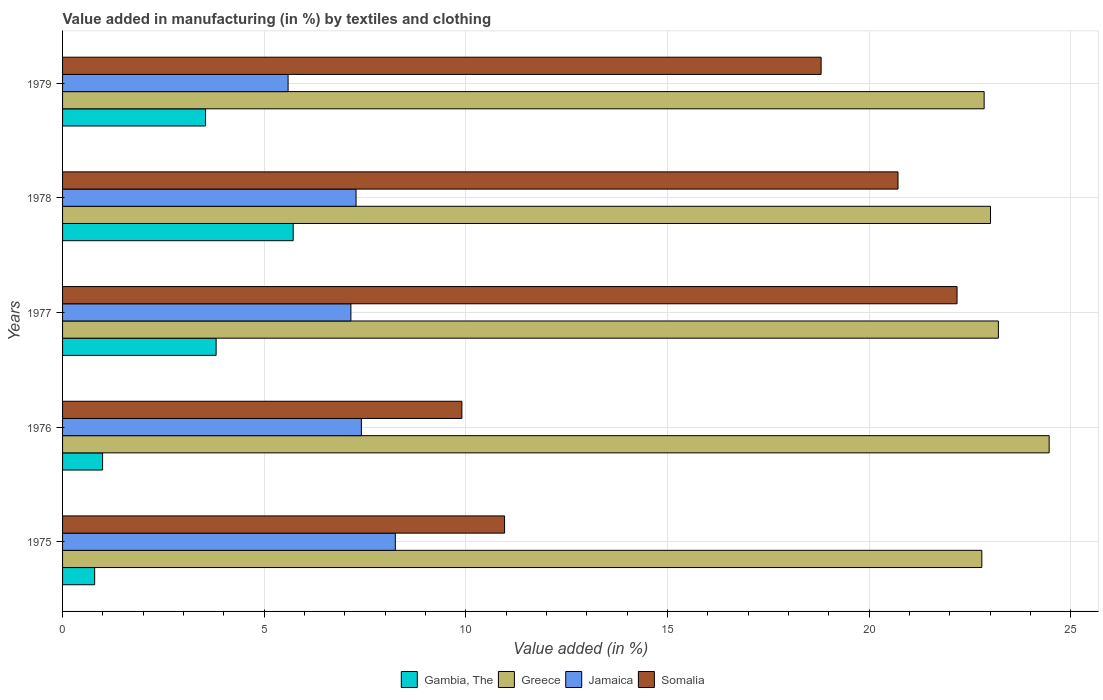Are the number of bars per tick equal to the number of legend labels?
Offer a terse response. Yes. How many bars are there on the 1st tick from the top?
Provide a succinct answer. 4. What is the label of the 1st group of bars from the top?
Provide a succinct answer. 1979. In how many cases, is the number of bars for a given year not equal to the number of legend labels?
Offer a terse response. 0. What is the percentage of value added in manufacturing by textiles and clothing in Somalia in 1978?
Provide a short and direct response. 20.72. Across all years, what is the maximum percentage of value added in manufacturing by textiles and clothing in Jamaica?
Provide a succinct answer. 8.25. Across all years, what is the minimum percentage of value added in manufacturing by textiles and clothing in Gambia, The?
Make the answer very short. 0.8. In which year was the percentage of value added in manufacturing by textiles and clothing in Jamaica maximum?
Offer a very short reply. 1975. In which year was the percentage of value added in manufacturing by textiles and clothing in Jamaica minimum?
Give a very brief answer. 1979. What is the total percentage of value added in manufacturing by textiles and clothing in Greece in the graph?
Make the answer very short. 116.32. What is the difference between the percentage of value added in manufacturing by textiles and clothing in Greece in 1975 and that in 1976?
Your answer should be very brief. -1.67. What is the difference between the percentage of value added in manufacturing by textiles and clothing in Gambia, The in 1978 and the percentage of value added in manufacturing by textiles and clothing in Somalia in 1976?
Make the answer very short. -4.18. What is the average percentage of value added in manufacturing by textiles and clothing in Greece per year?
Offer a very short reply. 23.26. In the year 1976, what is the difference between the percentage of value added in manufacturing by textiles and clothing in Gambia, The and percentage of value added in manufacturing by textiles and clothing in Greece?
Your answer should be compact. -23.47. In how many years, is the percentage of value added in manufacturing by textiles and clothing in Somalia greater than 23 %?
Make the answer very short. 0. What is the ratio of the percentage of value added in manufacturing by textiles and clothing in Jamaica in 1975 to that in 1976?
Your answer should be very brief. 1.11. Is the difference between the percentage of value added in manufacturing by textiles and clothing in Gambia, The in 1976 and 1979 greater than the difference between the percentage of value added in manufacturing by textiles and clothing in Greece in 1976 and 1979?
Your answer should be very brief. No. What is the difference between the highest and the second highest percentage of value added in manufacturing by textiles and clothing in Somalia?
Offer a very short reply. 1.46. What is the difference between the highest and the lowest percentage of value added in manufacturing by textiles and clothing in Gambia, The?
Make the answer very short. 4.92. In how many years, is the percentage of value added in manufacturing by textiles and clothing in Jamaica greater than the average percentage of value added in manufacturing by textiles and clothing in Jamaica taken over all years?
Ensure brevity in your answer.  4. Is it the case that in every year, the sum of the percentage of value added in manufacturing by textiles and clothing in Somalia and percentage of value added in manufacturing by textiles and clothing in Gambia, The is greater than the sum of percentage of value added in manufacturing by textiles and clothing in Jamaica and percentage of value added in manufacturing by textiles and clothing in Greece?
Offer a terse response. No. What does the 4th bar from the bottom in 1975 represents?
Offer a very short reply. Somalia. Are all the bars in the graph horizontal?
Your response must be concise. Yes. Are the values on the major ticks of X-axis written in scientific E-notation?
Your response must be concise. No. Does the graph contain any zero values?
Ensure brevity in your answer.  No. Does the graph contain grids?
Offer a terse response. Yes. How many legend labels are there?
Offer a very short reply. 4. How are the legend labels stacked?
Your answer should be very brief. Horizontal. What is the title of the graph?
Your answer should be compact. Value added in manufacturing (in %) by textiles and clothing. What is the label or title of the X-axis?
Ensure brevity in your answer.  Value added (in %). What is the Value added (in %) of Gambia, The in 1975?
Your answer should be compact. 0.8. What is the Value added (in %) of Greece in 1975?
Offer a very short reply. 22.79. What is the Value added (in %) of Jamaica in 1975?
Your answer should be compact. 8.25. What is the Value added (in %) in Somalia in 1975?
Your response must be concise. 10.96. What is the Value added (in %) in Gambia, The in 1976?
Provide a short and direct response. 0.99. What is the Value added (in %) in Greece in 1976?
Ensure brevity in your answer.  24.46. What is the Value added (in %) in Jamaica in 1976?
Offer a terse response. 7.41. What is the Value added (in %) in Somalia in 1976?
Offer a terse response. 9.9. What is the Value added (in %) of Gambia, The in 1977?
Make the answer very short. 3.81. What is the Value added (in %) in Greece in 1977?
Offer a terse response. 23.2. What is the Value added (in %) in Jamaica in 1977?
Offer a terse response. 7.15. What is the Value added (in %) of Somalia in 1977?
Your response must be concise. 22.18. What is the Value added (in %) of Gambia, The in 1978?
Offer a terse response. 5.72. What is the Value added (in %) in Greece in 1978?
Provide a short and direct response. 23.01. What is the Value added (in %) in Jamaica in 1978?
Make the answer very short. 7.28. What is the Value added (in %) in Somalia in 1978?
Provide a short and direct response. 20.72. What is the Value added (in %) of Gambia, The in 1979?
Provide a short and direct response. 3.55. What is the Value added (in %) of Greece in 1979?
Provide a succinct answer. 22.85. What is the Value added (in %) of Jamaica in 1979?
Your answer should be very brief. 5.59. What is the Value added (in %) of Somalia in 1979?
Your response must be concise. 18.81. Across all years, what is the maximum Value added (in %) of Gambia, The?
Your answer should be very brief. 5.72. Across all years, what is the maximum Value added (in %) in Greece?
Provide a succinct answer. 24.46. Across all years, what is the maximum Value added (in %) in Jamaica?
Your answer should be compact. 8.25. Across all years, what is the maximum Value added (in %) of Somalia?
Offer a very short reply. 22.18. Across all years, what is the minimum Value added (in %) in Gambia, The?
Provide a short and direct response. 0.8. Across all years, what is the minimum Value added (in %) of Greece?
Your answer should be compact. 22.79. Across all years, what is the minimum Value added (in %) in Jamaica?
Your answer should be very brief. 5.59. Across all years, what is the minimum Value added (in %) of Somalia?
Keep it short and to the point. 9.9. What is the total Value added (in %) of Gambia, The in the graph?
Your answer should be very brief. 14.86. What is the total Value added (in %) in Greece in the graph?
Provide a succinct answer. 116.32. What is the total Value added (in %) of Jamaica in the graph?
Your answer should be very brief. 35.68. What is the total Value added (in %) of Somalia in the graph?
Offer a very short reply. 82.57. What is the difference between the Value added (in %) of Gambia, The in 1975 and that in 1976?
Provide a short and direct response. -0.2. What is the difference between the Value added (in %) in Greece in 1975 and that in 1976?
Make the answer very short. -1.67. What is the difference between the Value added (in %) of Jamaica in 1975 and that in 1976?
Provide a short and direct response. 0.84. What is the difference between the Value added (in %) of Somalia in 1975 and that in 1976?
Your answer should be compact. 1.06. What is the difference between the Value added (in %) of Gambia, The in 1975 and that in 1977?
Provide a succinct answer. -3.01. What is the difference between the Value added (in %) of Greece in 1975 and that in 1977?
Offer a very short reply. -0.41. What is the difference between the Value added (in %) of Jamaica in 1975 and that in 1977?
Ensure brevity in your answer.  1.1. What is the difference between the Value added (in %) in Somalia in 1975 and that in 1977?
Ensure brevity in your answer.  -11.22. What is the difference between the Value added (in %) of Gambia, The in 1975 and that in 1978?
Your response must be concise. -4.92. What is the difference between the Value added (in %) of Greece in 1975 and that in 1978?
Offer a very short reply. -0.22. What is the difference between the Value added (in %) of Jamaica in 1975 and that in 1978?
Offer a terse response. 0.97. What is the difference between the Value added (in %) of Somalia in 1975 and that in 1978?
Keep it short and to the point. -9.76. What is the difference between the Value added (in %) in Gambia, The in 1975 and that in 1979?
Your response must be concise. -2.75. What is the difference between the Value added (in %) in Greece in 1975 and that in 1979?
Offer a very short reply. -0.06. What is the difference between the Value added (in %) in Jamaica in 1975 and that in 1979?
Make the answer very short. 2.66. What is the difference between the Value added (in %) in Somalia in 1975 and that in 1979?
Provide a short and direct response. -7.85. What is the difference between the Value added (in %) in Gambia, The in 1976 and that in 1977?
Your response must be concise. -2.81. What is the difference between the Value added (in %) of Greece in 1976 and that in 1977?
Your answer should be very brief. 1.26. What is the difference between the Value added (in %) of Jamaica in 1976 and that in 1977?
Offer a terse response. 0.26. What is the difference between the Value added (in %) in Somalia in 1976 and that in 1977?
Provide a short and direct response. -12.28. What is the difference between the Value added (in %) in Gambia, The in 1976 and that in 1978?
Ensure brevity in your answer.  -4.73. What is the difference between the Value added (in %) of Greece in 1976 and that in 1978?
Keep it short and to the point. 1.45. What is the difference between the Value added (in %) in Jamaica in 1976 and that in 1978?
Ensure brevity in your answer.  0.13. What is the difference between the Value added (in %) of Somalia in 1976 and that in 1978?
Your answer should be very brief. -10.81. What is the difference between the Value added (in %) of Gambia, The in 1976 and that in 1979?
Ensure brevity in your answer.  -2.55. What is the difference between the Value added (in %) in Greece in 1976 and that in 1979?
Make the answer very short. 1.61. What is the difference between the Value added (in %) of Jamaica in 1976 and that in 1979?
Make the answer very short. 1.82. What is the difference between the Value added (in %) of Somalia in 1976 and that in 1979?
Provide a succinct answer. -8.91. What is the difference between the Value added (in %) in Gambia, The in 1977 and that in 1978?
Offer a terse response. -1.91. What is the difference between the Value added (in %) in Greece in 1977 and that in 1978?
Provide a succinct answer. 0.2. What is the difference between the Value added (in %) of Jamaica in 1977 and that in 1978?
Provide a succinct answer. -0.13. What is the difference between the Value added (in %) in Somalia in 1977 and that in 1978?
Your response must be concise. 1.46. What is the difference between the Value added (in %) of Gambia, The in 1977 and that in 1979?
Make the answer very short. 0.26. What is the difference between the Value added (in %) of Greece in 1977 and that in 1979?
Give a very brief answer. 0.35. What is the difference between the Value added (in %) of Jamaica in 1977 and that in 1979?
Keep it short and to the point. 1.56. What is the difference between the Value added (in %) of Somalia in 1977 and that in 1979?
Offer a very short reply. 3.37. What is the difference between the Value added (in %) in Gambia, The in 1978 and that in 1979?
Your answer should be compact. 2.17. What is the difference between the Value added (in %) of Greece in 1978 and that in 1979?
Your response must be concise. 0.16. What is the difference between the Value added (in %) in Jamaica in 1978 and that in 1979?
Your answer should be very brief. 1.69. What is the difference between the Value added (in %) in Somalia in 1978 and that in 1979?
Your response must be concise. 1.91. What is the difference between the Value added (in %) of Gambia, The in 1975 and the Value added (in %) of Greece in 1976?
Your answer should be very brief. -23.67. What is the difference between the Value added (in %) in Gambia, The in 1975 and the Value added (in %) in Jamaica in 1976?
Your answer should be very brief. -6.61. What is the difference between the Value added (in %) in Gambia, The in 1975 and the Value added (in %) in Somalia in 1976?
Your response must be concise. -9.11. What is the difference between the Value added (in %) in Greece in 1975 and the Value added (in %) in Jamaica in 1976?
Make the answer very short. 15.38. What is the difference between the Value added (in %) in Greece in 1975 and the Value added (in %) in Somalia in 1976?
Provide a short and direct response. 12.89. What is the difference between the Value added (in %) of Jamaica in 1975 and the Value added (in %) of Somalia in 1976?
Ensure brevity in your answer.  -1.65. What is the difference between the Value added (in %) in Gambia, The in 1975 and the Value added (in %) in Greece in 1977?
Provide a short and direct response. -22.41. What is the difference between the Value added (in %) of Gambia, The in 1975 and the Value added (in %) of Jamaica in 1977?
Provide a succinct answer. -6.35. What is the difference between the Value added (in %) in Gambia, The in 1975 and the Value added (in %) in Somalia in 1977?
Provide a short and direct response. -21.38. What is the difference between the Value added (in %) of Greece in 1975 and the Value added (in %) of Jamaica in 1977?
Provide a succinct answer. 15.64. What is the difference between the Value added (in %) in Greece in 1975 and the Value added (in %) in Somalia in 1977?
Offer a very short reply. 0.61. What is the difference between the Value added (in %) in Jamaica in 1975 and the Value added (in %) in Somalia in 1977?
Ensure brevity in your answer.  -13.93. What is the difference between the Value added (in %) of Gambia, The in 1975 and the Value added (in %) of Greece in 1978?
Offer a terse response. -22.21. What is the difference between the Value added (in %) in Gambia, The in 1975 and the Value added (in %) in Jamaica in 1978?
Your response must be concise. -6.48. What is the difference between the Value added (in %) in Gambia, The in 1975 and the Value added (in %) in Somalia in 1978?
Your response must be concise. -19.92. What is the difference between the Value added (in %) in Greece in 1975 and the Value added (in %) in Jamaica in 1978?
Keep it short and to the point. 15.52. What is the difference between the Value added (in %) of Greece in 1975 and the Value added (in %) of Somalia in 1978?
Your answer should be compact. 2.08. What is the difference between the Value added (in %) in Jamaica in 1975 and the Value added (in %) in Somalia in 1978?
Keep it short and to the point. -12.46. What is the difference between the Value added (in %) of Gambia, The in 1975 and the Value added (in %) of Greece in 1979?
Your answer should be compact. -22.06. What is the difference between the Value added (in %) in Gambia, The in 1975 and the Value added (in %) in Jamaica in 1979?
Ensure brevity in your answer.  -4.8. What is the difference between the Value added (in %) of Gambia, The in 1975 and the Value added (in %) of Somalia in 1979?
Ensure brevity in your answer.  -18.01. What is the difference between the Value added (in %) in Greece in 1975 and the Value added (in %) in Jamaica in 1979?
Make the answer very short. 17.2. What is the difference between the Value added (in %) of Greece in 1975 and the Value added (in %) of Somalia in 1979?
Offer a very short reply. 3.98. What is the difference between the Value added (in %) of Jamaica in 1975 and the Value added (in %) of Somalia in 1979?
Your response must be concise. -10.56. What is the difference between the Value added (in %) in Gambia, The in 1976 and the Value added (in %) in Greece in 1977?
Offer a very short reply. -22.21. What is the difference between the Value added (in %) of Gambia, The in 1976 and the Value added (in %) of Jamaica in 1977?
Give a very brief answer. -6.16. What is the difference between the Value added (in %) of Gambia, The in 1976 and the Value added (in %) of Somalia in 1977?
Your response must be concise. -21.19. What is the difference between the Value added (in %) of Greece in 1976 and the Value added (in %) of Jamaica in 1977?
Your response must be concise. 17.31. What is the difference between the Value added (in %) of Greece in 1976 and the Value added (in %) of Somalia in 1977?
Make the answer very short. 2.28. What is the difference between the Value added (in %) in Jamaica in 1976 and the Value added (in %) in Somalia in 1977?
Provide a succinct answer. -14.77. What is the difference between the Value added (in %) of Gambia, The in 1976 and the Value added (in %) of Greece in 1978?
Offer a very short reply. -22.02. What is the difference between the Value added (in %) in Gambia, The in 1976 and the Value added (in %) in Jamaica in 1978?
Your answer should be very brief. -6.29. What is the difference between the Value added (in %) in Gambia, The in 1976 and the Value added (in %) in Somalia in 1978?
Keep it short and to the point. -19.72. What is the difference between the Value added (in %) of Greece in 1976 and the Value added (in %) of Jamaica in 1978?
Make the answer very short. 17.19. What is the difference between the Value added (in %) of Greece in 1976 and the Value added (in %) of Somalia in 1978?
Your answer should be very brief. 3.75. What is the difference between the Value added (in %) in Jamaica in 1976 and the Value added (in %) in Somalia in 1978?
Your response must be concise. -13.31. What is the difference between the Value added (in %) in Gambia, The in 1976 and the Value added (in %) in Greece in 1979?
Keep it short and to the point. -21.86. What is the difference between the Value added (in %) in Gambia, The in 1976 and the Value added (in %) in Jamaica in 1979?
Offer a very short reply. -4.6. What is the difference between the Value added (in %) in Gambia, The in 1976 and the Value added (in %) in Somalia in 1979?
Offer a very short reply. -17.82. What is the difference between the Value added (in %) of Greece in 1976 and the Value added (in %) of Jamaica in 1979?
Give a very brief answer. 18.87. What is the difference between the Value added (in %) of Greece in 1976 and the Value added (in %) of Somalia in 1979?
Your response must be concise. 5.65. What is the difference between the Value added (in %) in Jamaica in 1976 and the Value added (in %) in Somalia in 1979?
Keep it short and to the point. -11.4. What is the difference between the Value added (in %) in Gambia, The in 1977 and the Value added (in %) in Greece in 1978?
Keep it short and to the point. -19.2. What is the difference between the Value added (in %) of Gambia, The in 1977 and the Value added (in %) of Jamaica in 1978?
Provide a short and direct response. -3.47. What is the difference between the Value added (in %) in Gambia, The in 1977 and the Value added (in %) in Somalia in 1978?
Your answer should be very brief. -16.91. What is the difference between the Value added (in %) in Greece in 1977 and the Value added (in %) in Jamaica in 1978?
Your answer should be very brief. 15.93. What is the difference between the Value added (in %) in Greece in 1977 and the Value added (in %) in Somalia in 1978?
Your answer should be very brief. 2.49. What is the difference between the Value added (in %) of Jamaica in 1977 and the Value added (in %) of Somalia in 1978?
Provide a short and direct response. -13.57. What is the difference between the Value added (in %) of Gambia, The in 1977 and the Value added (in %) of Greece in 1979?
Keep it short and to the point. -19.04. What is the difference between the Value added (in %) in Gambia, The in 1977 and the Value added (in %) in Jamaica in 1979?
Provide a succinct answer. -1.78. What is the difference between the Value added (in %) in Gambia, The in 1977 and the Value added (in %) in Somalia in 1979?
Give a very brief answer. -15. What is the difference between the Value added (in %) in Greece in 1977 and the Value added (in %) in Jamaica in 1979?
Your answer should be compact. 17.61. What is the difference between the Value added (in %) in Greece in 1977 and the Value added (in %) in Somalia in 1979?
Your answer should be very brief. 4.4. What is the difference between the Value added (in %) in Jamaica in 1977 and the Value added (in %) in Somalia in 1979?
Keep it short and to the point. -11.66. What is the difference between the Value added (in %) of Gambia, The in 1978 and the Value added (in %) of Greece in 1979?
Your answer should be compact. -17.13. What is the difference between the Value added (in %) of Gambia, The in 1978 and the Value added (in %) of Jamaica in 1979?
Offer a terse response. 0.13. What is the difference between the Value added (in %) of Gambia, The in 1978 and the Value added (in %) of Somalia in 1979?
Keep it short and to the point. -13.09. What is the difference between the Value added (in %) in Greece in 1978 and the Value added (in %) in Jamaica in 1979?
Your response must be concise. 17.42. What is the difference between the Value added (in %) in Greece in 1978 and the Value added (in %) in Somalia in 1979?
Provide a succinct answer. 4.2. What is the difference between the Value added (in %) of Jamaica in 1978 and the Value added (in %) of Somalia in 1979?
Offer a terse response. -11.53. What is the average Value added (in %) of Gambia, The per year?
Ensure brevity in your answer.  2.97. What is the average Value added (in %) in Greece per year?
Keep it short and to the point. 23.26. What is the average Value added (in %) of Jamaica per year?
Give a very brief answer. 7.14. What is the average Value added (in %) of Somalia per year?
Provide a succinct answer. 16.51. In the year 1975, what is the difference between the Value added (in %) of Gambia, The and Value added (in %) of Greece?
Ensure brevity in your answer.  -22. In the year 1975, what is the difference between the Value added (in %) in Gambia, The and Value added (in %) in Jamaica?
Give a very brief answer. -7.46. In the year 1975, what is the difference between the Value added (in %) in Gambia, The and Value added (in %) in Somalia?
Ensure brevity in your answer.  -10.16. In the year 1975, what is the difference between the Value added (in %) in Greece and Value added (in %) in Jamaica?
Provide a succinct answer. 14.54. In the year 1975, what is the difference between the Value added (in %) in Greece and Value added (in %) in Somalia?
Keep it short and to the point. 11.83. In the year 1975, what is the difference between the Value added (in %) in Jamaica and Value added (in %) in Somalia?
Your answer should be very brief. -2.71. In the year 1976, what is the difference between the Value added (in %) in Gambia, The and Value added (in %) in Greece?
Provide a short and direct response. -23.47. In the year 1976, what is the difference between the Value added (in %) in Gambia, The and Value added (in %) in Jamaica?
Provide a succinct answer. -6.42. In the year 1976, what is the difference between the Value added (in %) in Gambia, The and Value added (in %) in Somalia?
Your answer should be compact. -8.91. In the year 1976, what is the difference between the Value added (in %) in Greece and Value added (in %) in Jamaica?
Offer a very short reply. 17.05. In the year 1976, what is the difference between the Value added (in %) in Greece and Value added (in %) in Somalia?
Provide a succinct answer. 14.56. In the year 1976, what is the difference between the Value added (in %) of Jamaica and Value added (in %) of Somalia?
Give a very brief answer. -2.49. In the year 1977, what is the difference between the Value added (in %) in Gambia, The and Value added (in %) in Greece?
Offer a very short reply. -19.4. In the year 1977, what is the difference between the Value added (in %) in Gambia, The and Value added (in %) in Jamaica?
Offer a terse response. -3.34. In the year 1977, what is the difference between the Value added (in %) in Gambia, The and Value added (in %) in Somalia?
Your answer should be compact. -18.37. In the year 1977, what is the difference between the Value added (in %) in Greece and Value added (in %) in Jamaica?
Your response must be concise. 16.05. In the year 1977, what is the difference between the Value added (in %) in Greece and Value added (in %) in Somalia?
Your answer should be compact. 1.03. In the year 1977, what is the difference between the Value added (in %) in Jamaica and Value added (in %) in Somalia?
Your answer should be compact. -15.03. In the year 1978, what is the difference between the Value added (in %) in Gambia, The and Value added (in %) in Greece?
Your response must be concise. -17.29. In the year 1978, what is the difference between the Value added (in %) of Gambia, The and Value added (in %) of Jamaica?
Keep it short and to the point. -1.56. In the year 1978, what is the difference between the Value added (in %) in Gambia, The and Value added (in %) in Somalia?
Give a very brief answer. -15. In the year 1978, what is the difference between the Value added (in %) of Greece and Value added (in %) of Jamaica?
Ensure brevity in your answer.  15.73. In the year 1978, what is the difference between the Value added (in %) in Greece and Value added (in %) in Somalia?
Your answer should be compact. 2.29. In the year 1978, what is the difference between the Value added (in %) in Jamaica and Value added (in %) in Somalia?
Give a very brief answer. -13.44. In the year 1979, what is the difference between the Value added (in %) of Gambia, The and Value added (in %) of Greece?
Offer a very short reply. -19.31. In the year 1979, what is the difference between the Value added (in %) of Gambia, The and Value added (in %) of Jamaica?
Make the answer very short. -2.05. In the year 1979, what is the difference between the Value added (in %) in Gambia, The and Value added (in %) in Somalia?
Your answer should be very brief. -15.26. In the year 1979, what is the difference between the Value added (in %) of Greece and Value added (in %) of Jamaica?
Keep it short and to the point. 17.26. In the year 1979, what is the difference between the Value added (in %) in Greece and Value added (in %) in Somalia?
Give a very brief answer. 4.04. In the year 1979, what is the difference between the Value added (in %) of Jamaica and Value added (in %) of Somalia?
Make the answer very short. -13.22. What is the ratio of the Value added (in %) in Gambia, The in 1975 to that in 1976?
Your answer should be very brief. 0.8. What is the ratio of the Value added (in %) of Greece in 1975 to that in 1976?
Keep it short and to the point. 0.93. What is the ratio of the Value added (in %) in Jamaica in 1975 to that in 1976?
Provide a short and direct response. 1.11. What is the ratio of the Value added (in %) of Somalia in 1975 to that in 1976?
Your answer should be compact. 1.11. What is the ratio of the Value added (in %) in Gambia, The in 1975 to that in 1977?
Your answer should be very brief. 0.21. What is the ratio of the Value added (in %) of Greece in 1975 to that in 1977?
Your response must be concise. 0.98. What is the ratio of the Value added (in %) of Jamaica in 1975 to that in 1977?
Make the answer very short. 1.15. What is the ratio of the Value added (in %) in Somalia in 1975 to that in 1977?
Keep it short and to the point. 0.49. What is the ratio of the Value added (in %) of Gambia, The in 1975 to that in 1978?
Keep it short and to the point. 0.14. What is the ratio of the Value added (in %) in Greece in 1975 to that in 1978?
Your answer should be very brief. 0.99. What is the ratio of the Value added (in %) in Jamaica in 1975 to that in 1978?
Make the answer very short. 1.13. What is the ratio of the Value added (in %) of Somalia in 1975 to that in 1978?
Your answer should be very brief. 0.53. What is the ratio of the Value added (in %) in Gambia, The in 1975 to that in 1979?
Ensure brevity in your answer.  0.22. What is the ratio of the Value added (in %) in Greece in 1975 to that in 1979?
Your answer should be compact. 1. What is the ratio of the Value added (in %) of Jamaica in 1975 to that in 1979?
Provide a succinct answer. 1.48. What is the ratio of the Value added (in %) in Somalia in 1975 to that in 1979?
Your answer should be very brief. 0.58. What is the ratio of the Value added (in %) in Gambia, The in 1976 to that in 1977?
Give a very brief answer. 0.26. What is the ratio of the Value added (in %) in Greece in 1976 to that in 1977?
Your answer should be very brief. 1.05. What is the ratio of the Value added (in %) of Jamaica in 1976 to that in 1977?
Offer a terse response. 1.04. What is the ratio of the Value added (in %) of Somalia in 1976 to that in 1977?
Provide a succinct answer. 0.45. What is the ratio of the Value added (in %) of Gambia, The in 1976 to that in 1978?
Give a very brief answer. 0.17. What is the ratio of the Value added (in %) in Greece in 1976 to that in 1978?
Provide a succinct answer. 1.06. What is the ratio of the Value added (in %) of Jamaica in 1976 to that in 1978?
Provide a succinct answer. 1.02. What is the ratio of the Value added (in %) in Somalia in 1976 to that in 1978?
Ensure brevity in your answer.  0.48. What is the ratio of the Value added (in %) of Gambia, The in 1976 to that in 1979?
Provide a succinct answer. 0.28. What is the ratio of the Value added (in %) of Greece in 1976 to that in 1979?
Offer a terse response. 1.07. What is the ratio of the Value added (in %) in Jamaica in 1976 to that in 1979?
Offer a very short reply. 1.32. What is the ratio of the Value added (in %) of Somalia in 1976 to that in 1979?
Offer a very short reply. 0.53. What is the ratio of the Value added (in %) of Gambia, The in 1977 to that in 1978?
Your answer should be very brief. 0.67. What is the ratio of the Value added (in %) of Greece in 1977 to that in 1978?
Keep it short and to the point. 1.01. What is the ratio of the Value added (in %) in Jamaica in 1977 to that in 1978?
Offer a terse response. 0.98. What is the ratio of the Value added (in %) in Somalia in 1977 to that in 1978?
Your answer should be very brief. 1.07. What is the ratio of the Value added (in %) in Gambia, The in 1977 to that in 1979?
Provide a short and direct response. 1.07. What is the ratio of the Value added (in %) of Greece in 1977 to that in 1979?
Offer a very short reply. 1.02. What is the ratio of the Value added (in %) in Jamaica in 1977 to that in 1979?
Your answer should be very brief. 1.28. What is the ratio of the Value added (in %) of Somalia in 1977 to that in 1979?
Offer a very short reply. 1.18. What is the ratio of the Value added (in %) of Gambia, The in 1978 to that in 1979?
Offer a terse response. 1.61. What is the ratio of the Value added (in %) in Greece in 1978 to that in 1979?
Ensure brevity in your answer.  1.01. What is the ratio of the Value added (in %) of Jamaica in 1978 to that in 1979?
Provide a succinct answer. 1.3. What is the ratio of the Value added (in %) in Somalia in 1978 to that in 1979?
Offer a very short reply. 1.1. What is the difference between the highest and the second highest Value added (in %) of Gambia, The?
Your answer should be compact. 1.91. What is the difference between the highest and the second highest Value added (in %) in Greece?
Give a very brief answer. 1.26. What is the difference between the highest and the second highest Value added (in %) in Jamaica?
Provide a succinct answer. 0.84. What is the difference between the highest and the second highest Value added (in %) of Somalia?
Offer a terse response. 1.46. What is the difference between the highest and the lowest Value added (in %) of Gambia, The?
Ensure brevity in your answer.  4.92. What is the difference between the highest and the lowest Value added (in %) in Greece?
Give a very brief answer. 1.67. What is the difference between the highest and the lowest Value added (in %) in Jamaica?
Provide a succinct answer. 2.66. What is the difference between the highest and the lowest Value added (in %) of Somalia?
Provide a succinct answer. 12.28. 